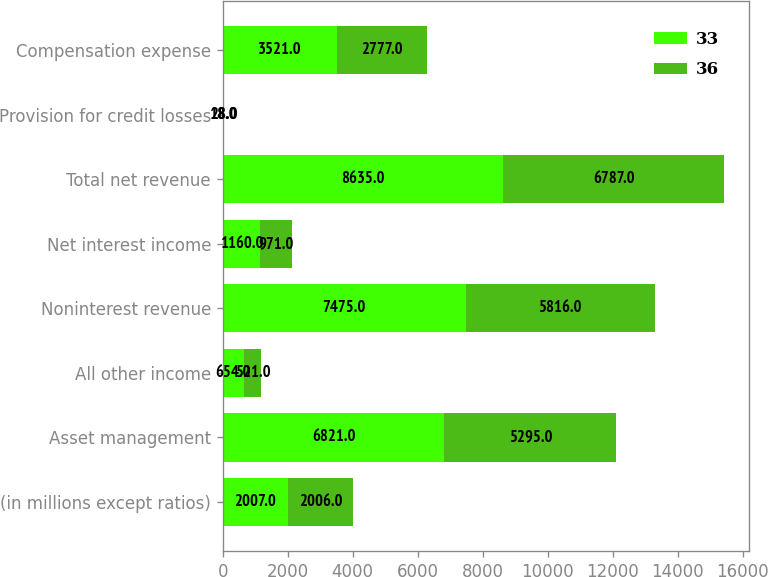Convert chart to OTSL. <chart><loc_0><loc_0><loc_500><loc_500><stacked_bar_chart><ecel><fcel>(in millions except ratios)<fcel>Asset management<fcel>All other income<fcel>Noninterest revenue<fcel>Net interest income<fcel>Total net revenue<fcel>Provision for credit losses<fcel>Compensation expense<nl><fcel>33<fcel>2007<fcel>6821<fcel>654<fcel>7475<fcel>1160<fcel>8635<fcel>18<fcel>3521<nl><fcel>36<fcel>2006<fcel>5295<fcel>521<fcel>5816<fcel>971<fcel>6787<fcel>28<fcel>2777<nl></chart> 